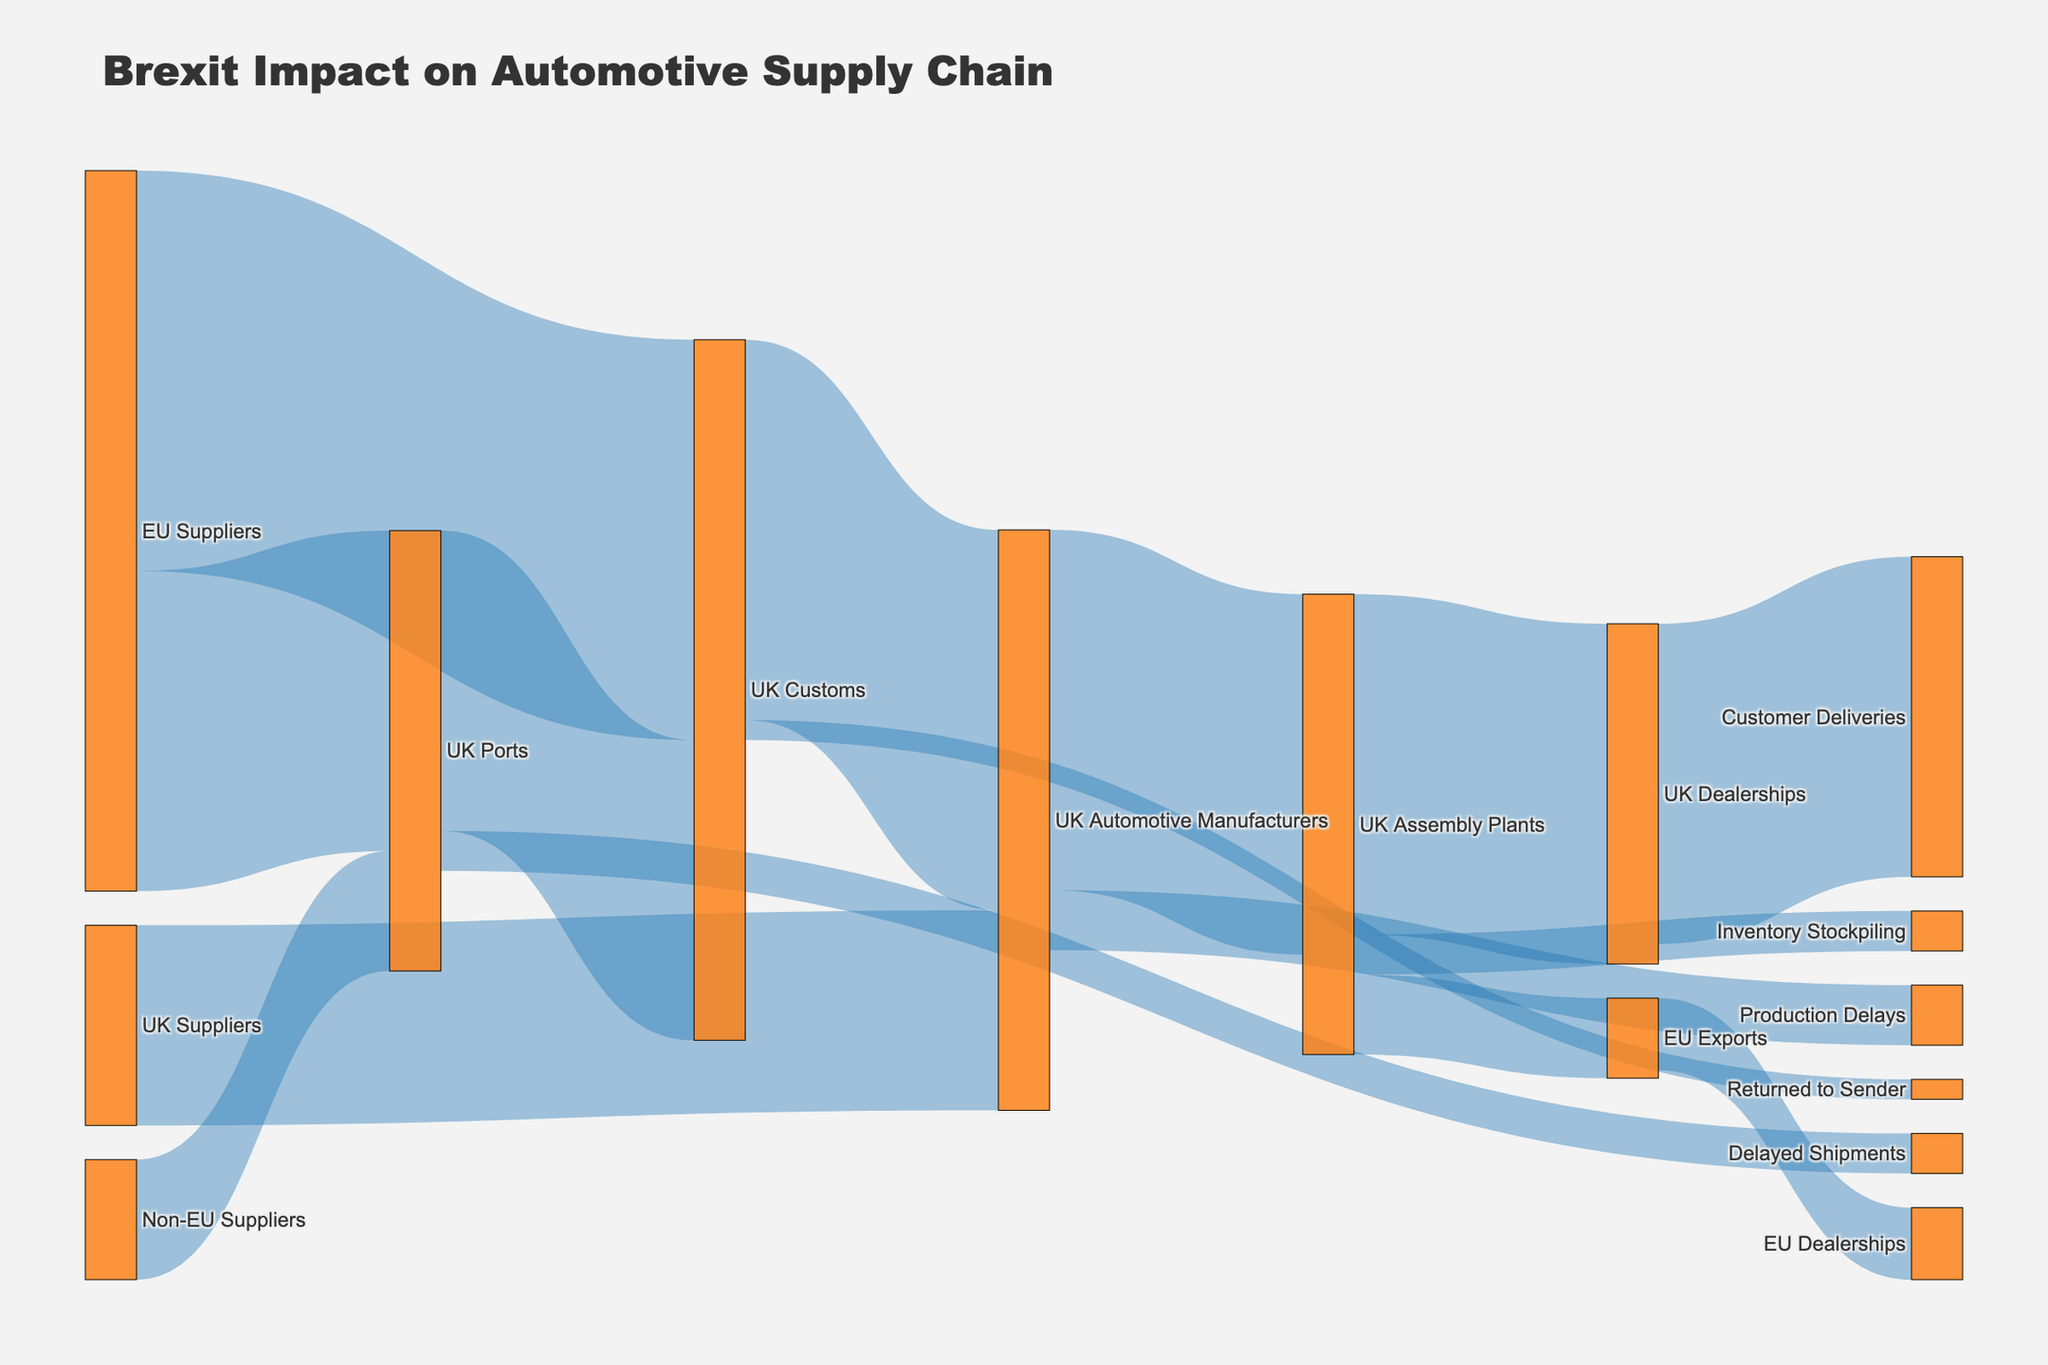What is the title of the Sankey diagram? The title of the Sankey diagram is usually prominently displayed at the top of the figure. In this case, the title is "Brexit Impact on Automotive Supply Chain" as specified in the plot generation code.
Answer: Brexit Impact on Automotive Supply Chain Which node has the highest value flow into it? To determine which node has the highest value flow into it, examine the "target" nodes in the dataset and sum the incoming flows. The node "UK Customs" has the highest value flow into it, with 100,000 from "EU Suppliers" and 75,000 from "UK Ports," totaling 175,000.
Answer: UK Customs How much value flows from "UK Customs" to "UK Automotive Manufacturers"? The value flowing from "UK Customs" to "UK Automotive Manufacturers" is directly mentioned in the dataset as a specific flow value. It is listed as 95,000.
Answer: 95,000 Which node has the smallest outgoing flow, and what is its value? To find the smallest outgoing flow, examine the flows for each source node in the dataset. The smallest outgoing flow is from "UK Customs" to "Returned to Sender," which has a value of 5,000.
Answer: Returned to Sender, 5,000 Compare the values flowing into "UK Assembly Plants" from "UK Automotive Manufacturers" and "UK Suppliers." Which is higher and by how much? "UK Automotive Manufacturers" sends 90,000 to "UK Assembly Plants" and "UK Suppliers" sends 50,000. The difference is 90,000 - 50,000, so the value flowing from "UK Automotive Manufacturers" is higher by 40,000.
Answer: 90,000 from UK Automotive Manufacturers is higher by 40,000 What is the total value of materials and components flowing into "UK Dealerships"? The total value flowing into "UK Dealerships" is the sum of values from all source nodes leading to it. In this case, "UK Assembly Plants" sends 85,000 to "UK Dealerships."
Answer: 85,000 What are the top three nodes with the highest outgoing flows? Sum the outgoing flows for each node to find the top three. "EU Suppliers" has 100,000 to "UK Customs" and 80,000 to "UK Ports" (180,000 total), "UK Customs" has 95,000 to "UK Automotive Manufacturers," 75,000 to "UK Ports," and 5,000 to "Returned to Sender" (175,000 total), and "UK Automotive Manufacturers" has 90,000 to "UK Assembly Plants" and 15,000 to "Production Delays" (105,000 total). The top three nodes are "EU Suppliers" (180,000), "UK Customs" (175,000), and "UK Automotive Manufacturers" (105,000).
Answer: EU Suppliers, UK Customs, UK Automotive Manufacturers 